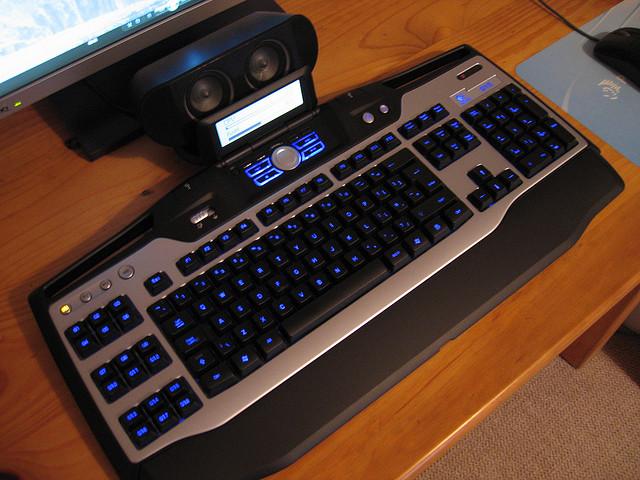What color is seen on the keyboard?
Be succinct. Blue. What is the device used to control?
Write a very short answer. Computer. What color is the mouse pad?
Short answer required. Blue. How can you know where you are using this phone?
Short answer required. Location device. Does this keyboard need to be sanitized?
Keep it brief. No. Is this keyboard meant for adults?
Short answer required. Yes. Is there a mouse in the picture?
Concise answer only. Yes. 